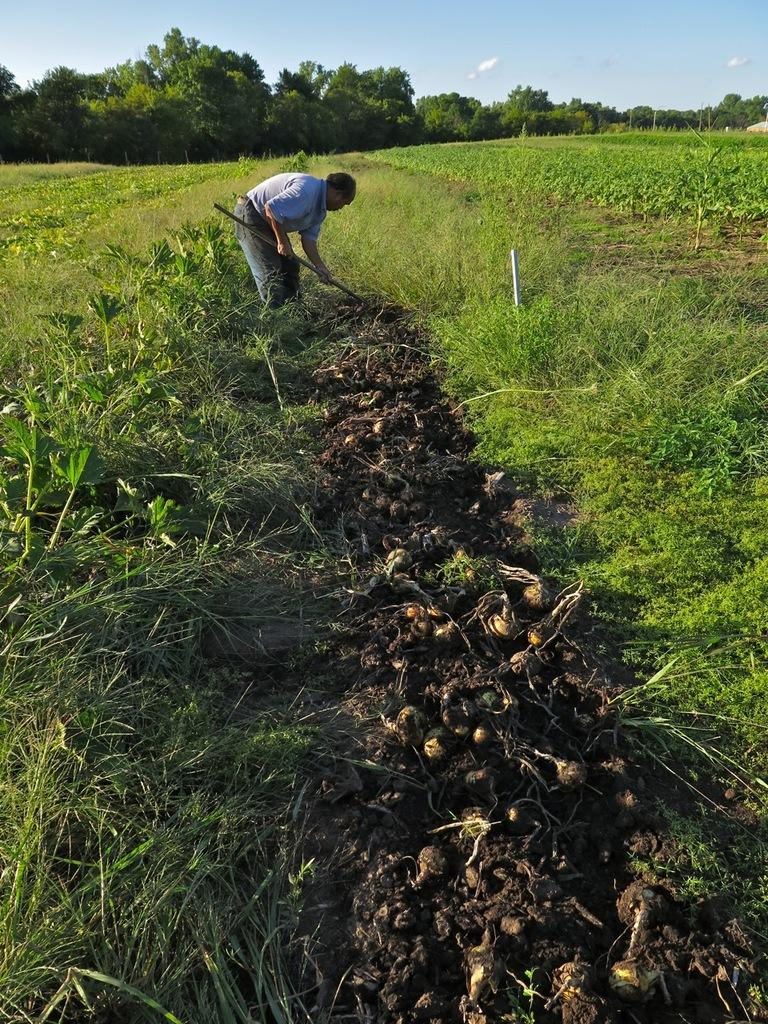Who is present in the image? There is a man in the image. Where is the man located in the image? The man is at the top side of the image. What is the man doing in the image? The man is digging the floor. What can be seen in the surroundings of the image? There is greenery around the area of the image. What type of bit is the man using to measure the depth of the hole he is digging? There is no bit or measuring tool visible in the image, and the man is simply digging the floor. 